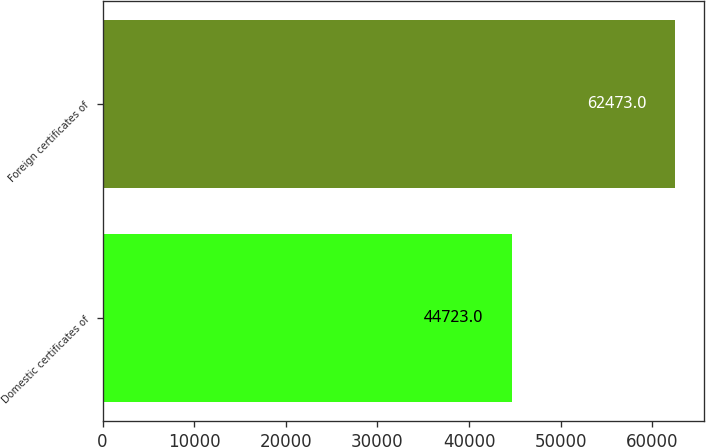Convert chart to OTSL. <chart><loc_0><loc_0><loc_500><loc_500><bar_chart><fcel>Domestic certificates of<fcel>Foreign certificates of<nl><fcel>44723<fcel>62473<nl></chart> 